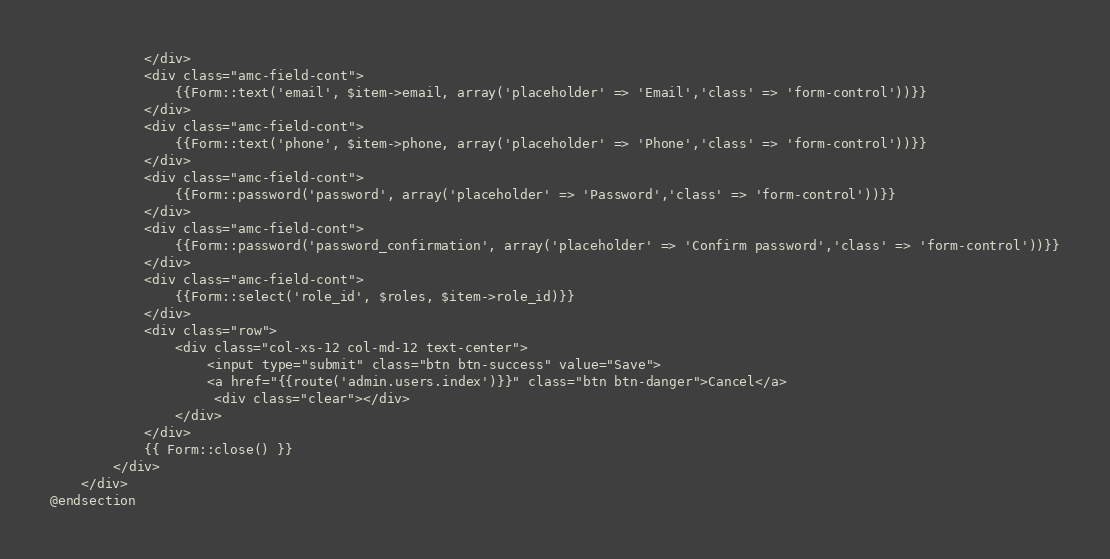Convert code to text. <code><loc_0><loc_0><loc_500><loc_500><_PHP_>		    </div>
			<div class="amc-field-cont">
				{{Form::text('email', $item->email, array('placeholder' => 'Email','class' => 'form-control'))}}
		    </div>
			<div class="amc-field-cont">
				{{Form::text('phone', $item->phone, array('placeholder' => 'Phone','class' => 'form-control'))}}
		    </div>
			<div class="amc-field-cont">
				{{Form::password('password', array('placeholder' => 'Password','class' => 'form-control'))}}
		    </div>
			<div class="amc-field-cont">
				{{Form::password('password_confirmation', array('placeholder' => 'Confirm password','class' => 'form-control'))}}
		    </div>
			<div class="amc-field-cont">
				{{Form::select('role_id', $roles, $item->role_id)}}
		    </div>
			<div class="row">
				<div class="col-xs-12 col-md-12 text-center">
					<input type="submit" class="btn btn-success" value="Save">
					<a href="{{route('admin.users.index')}}" class="btn btn-danger">Cancel</a>
					 <div class="clear"></div>
				</div>
			</div>
			{{ Form::close() }}
		</div>
	</div>
@endsection
</code> 